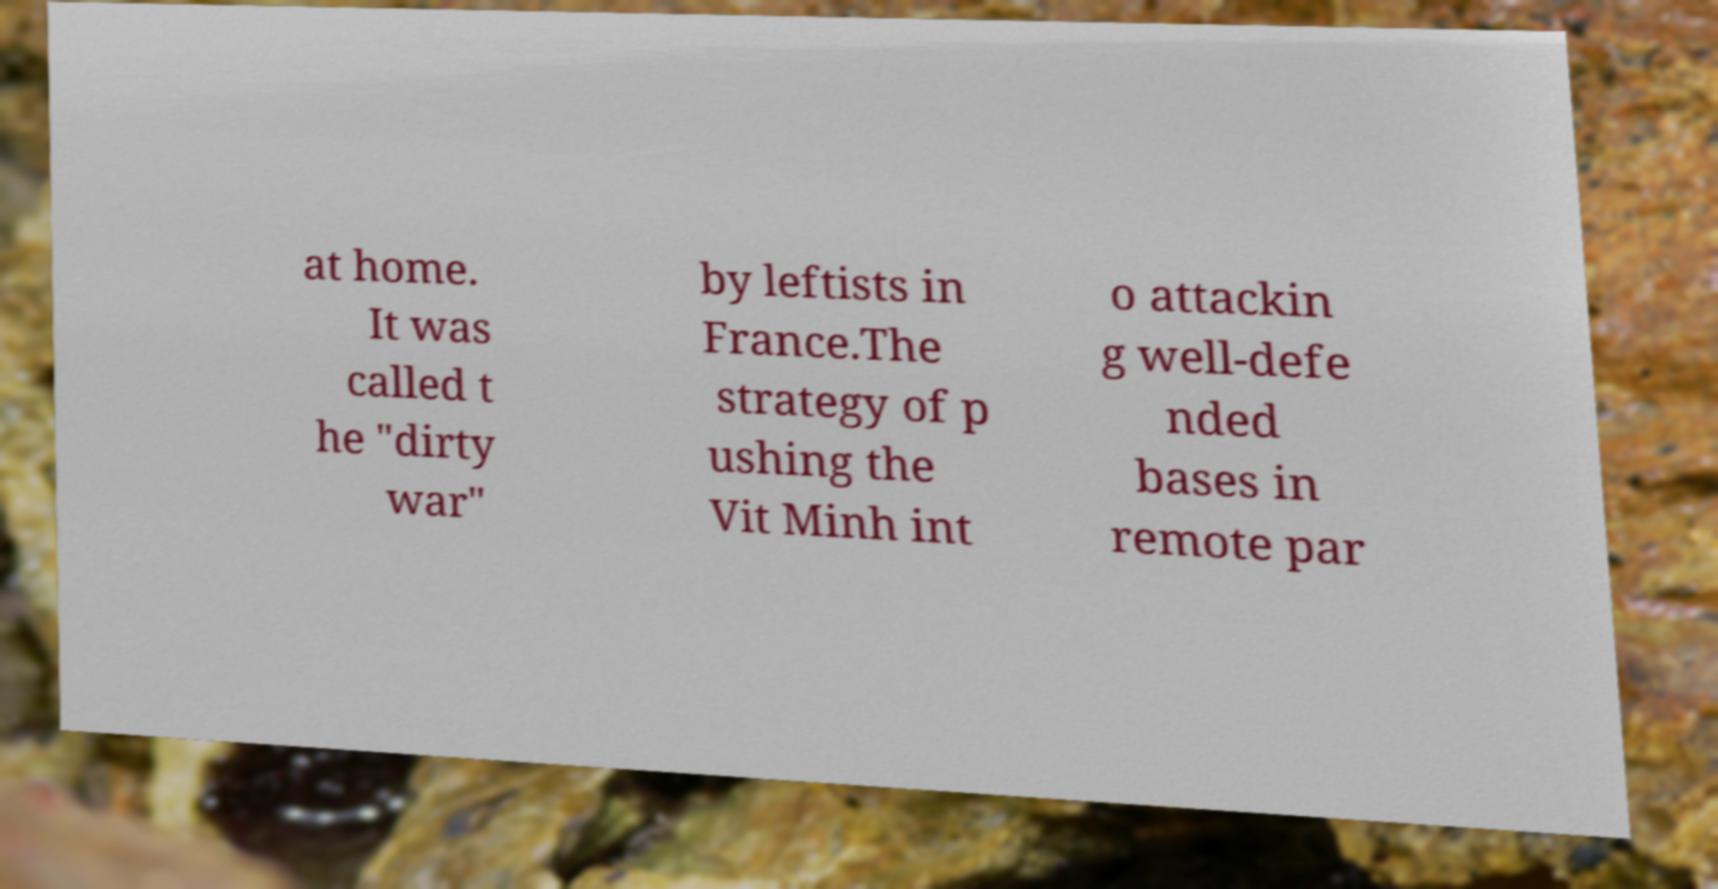For documentation purposes, I need the text within this image transcribed. Could you provide that? at home. It was called t he "dirty war" by leftists in France.The strategy of p ushing the Vit Minh int o attackin g well-defe nded bases in remote par 